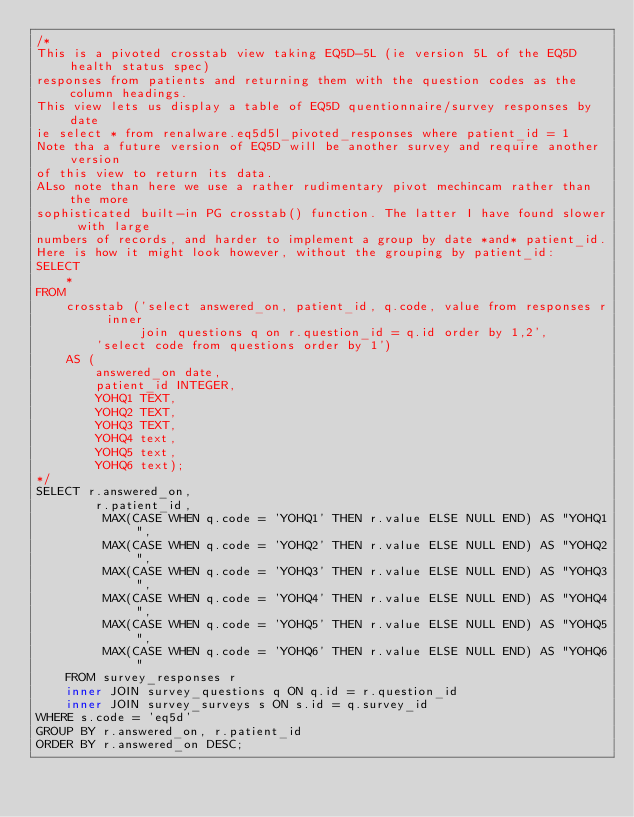<code> <loc_0><loc_0><loc_500><loc_500><_SQL_>/*
This is a pivoted crosstab view taking EQ5D-5L (ie version 5L of the EQ5D health status spec)
responses from patients and returning them with the question codes as the column headings.
This view lets us display a table of EQ5D quentionnaire/survey responses by date
ie select * from renalware.eq5d5l_pivoted_responses where patient_id = 1
Note tha a future version of EQ5D will be another survey and require another version
of this view to return its data.
ALso note than here we use a rather rudimentary pivot mechincam rather than the more
sophisticated built-in PG crosstab() function. The latter I have found slower with large
numbers of records, and harder to implement a group by date *and* patient_id.
Here is how it might look however, without the grouping by patient_id:
SELECT
    *
FROM
    crosstab ('select answered_on, patient_id, q.code, value from responses r inner
              join questions q on r.question_id = q.id order by 1,2',
        'select code from questions order by 1')
    AS (
        answered_on date,
        patient_id INTEGER,
        YOHQ1 TEXT,
        YOHQ2 TEXT,
        YOHQ3 TEXT,
        YOHQ4 text,
        YOHQ5 text,
        YOHQ6 text);
*/
SELECT r.answered_on,
        r.patient_id,
         MAX(CASE WHEN q.code = 'YOHQ1' THEN r.value ELSE NULL END) AS "YOHQ1",
         MAX(CASE WHEN q.code = 'YOHQ2' THEN r.value ELSE NULL END) AS "YOHQ2",
         MAX(CASE WHEN q.code = 'YOHQ3' THEN r.value ELSE NULL END) AS "YOHQ3",
         MAX(CASE WHEN q.code = 'YOHQ4' THEN r.value ELSE NULL END) AS "YOHQ4",
         MAX(CASE WHEN q.code = 'YOHQ5' THEN r.value ELSE NULL END) AS "YOHQ5",
         MAX(CASE WHEN q.code = 'YOHQ6' THEN r.value ELSE NULL END) AS "YOHQ6"
    FROM survey_responses r
    inner JOIN survey_questions q ON q.id = r.question_id
    inner JOIN survey_surveys s ON s.id = q.survey_id
WHERE s.code = 'eq5d'
GROUP BY r.answered_on, r.patient_id
ORDER BY r.answered_on DESC;
</code> 